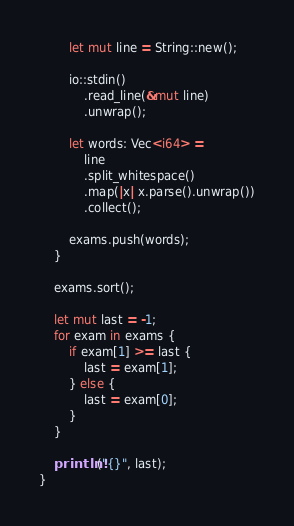<code> <loc_0><loc_0><loc_500><loc_500><_Rust_>        let mut line = String::new();

        io::stdin()
            .read_line(&mut line)
            .unwrap();

        let words: Vec<i64> =
            line
            .split_whitespace()
            .map(|x| x.parse().unwrap())
            .collect();

        exams.push(words);
    }

    exams.sort();

    let mut last = -1;
    for exam in exams {
        if exam[1] >= last {
            last = exam[1];
        } else {
            last = exam[0];
        }
    }

    println!("{}", last);
}
</code> 